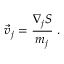<formula> <loc_0><loc_0><loc_500><loc_500>{ \vec { v } } _ { j } = { \frac { \nabla _ { j } S } { m _ { j } } } \, .</formula> 